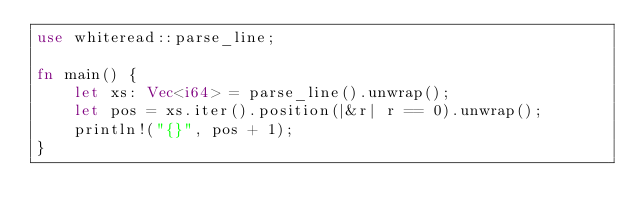Convert code to text. <code><loc_0><loc_0><loc_500><loc_500><_Rust_>use whiteread::parse_line;

fn main() {
    let xs: Vec<i64> = parse_line().unwrap();
    let pos = xs.iter().position(|&r| r == 0).unwrap();
    println!("{}", pos + 1);
}
</code> 